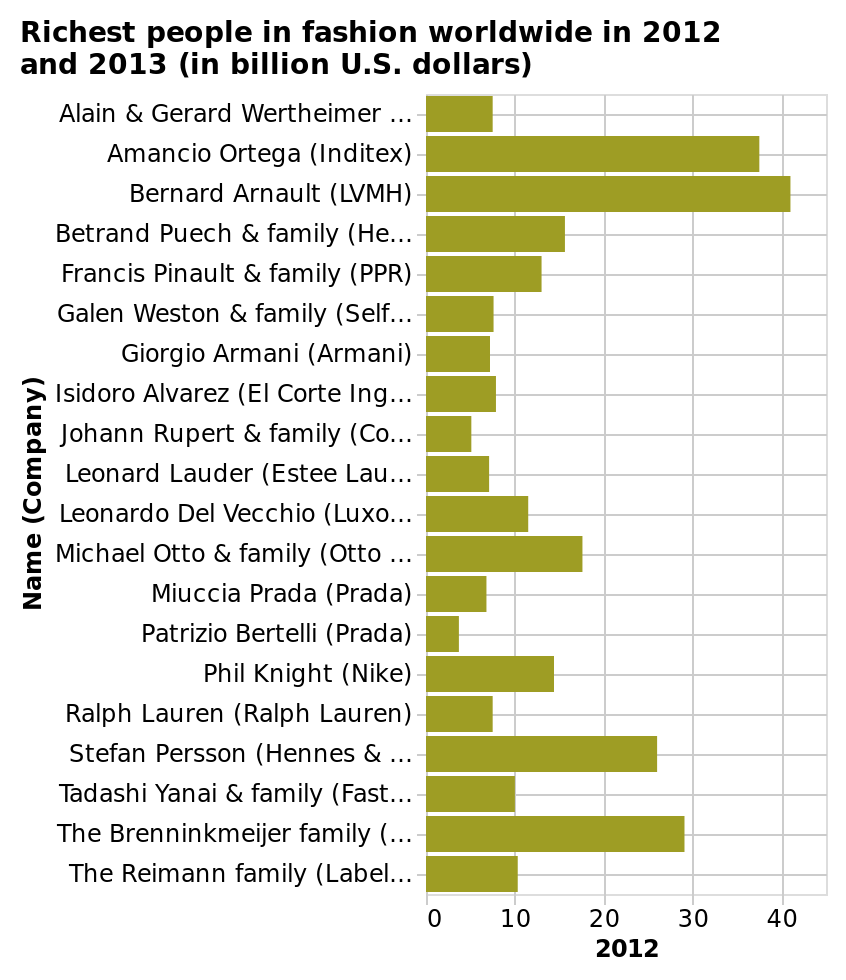<image>
Who was the person with the lowest wealth in fashion in 2012 and 2013? Patrizio Bertelli (Prada) had the lowest wealth in fashion worldwide in 2012 and 2013. Who topped the list as the wealthiest person in the fashion industry in 2012 and 2013? Bernard Arnault topped the list as the wealthiest person in the fashion industry worldwide in 2012 and 2013. 